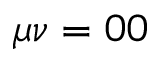Convert formula to latex. <formula><loc_0><loc_0><loc_500><loc_500>\mu \nu = 0 0</formula> 